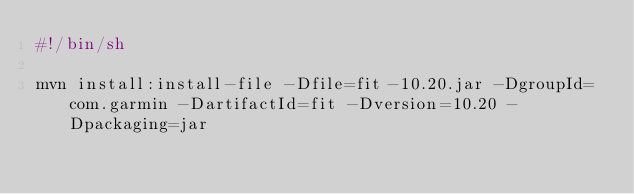Convert code to text. <code><loc_0><loc_0><loc_500><loc_500><_Bash_>#!/bin/sh

mvn install:install-file -Dfile=fit-10.20.jar -DgroupId=com.garmin -DartifactId=fit -Dversion=10.20 -Dpackaging=jar
</code> 